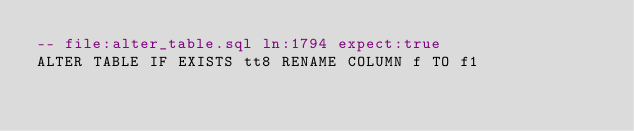Convert code to text. <code><loc_0><loc_0><loc_500><loc_500><_SQL_>-- file:alter_table.sql ln:1794 expect:true
ALTER TABLE IF EXISTS tt8 RENAME COLUMN f TO f1
</code> 